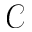<formula> <loc_0><loc_0><loc_500><loc_500>\mathcal { C }</formula> 